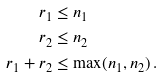Convert formula to latex. <formula><loc_0><loc_0><loc_500><loc_500>r _ { 1 } & \leq n _ { 1 } \\ r _ { 2 } & \leq n _ { 2 } \\ r _ { 1 } + r _ { 2 } & \leq \max ( n _ { 1 } , n _ { 2 } ) \, .</formula> 